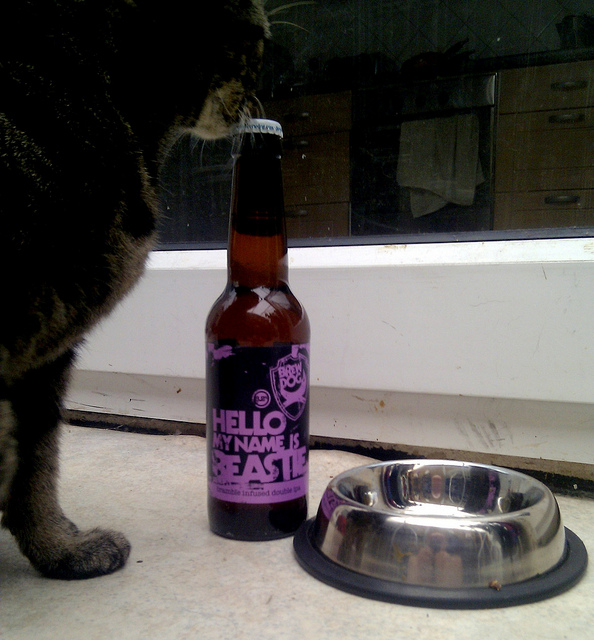<image>What company makes this beer? It is unknown what company makes this beer. It could be 'brewdog', 'beastie', or 'rogue'. What company makes this beer? I don't know which company makes this beer. It can be either Brewdog, Beastie, Rogue, Genesee or unknown. 